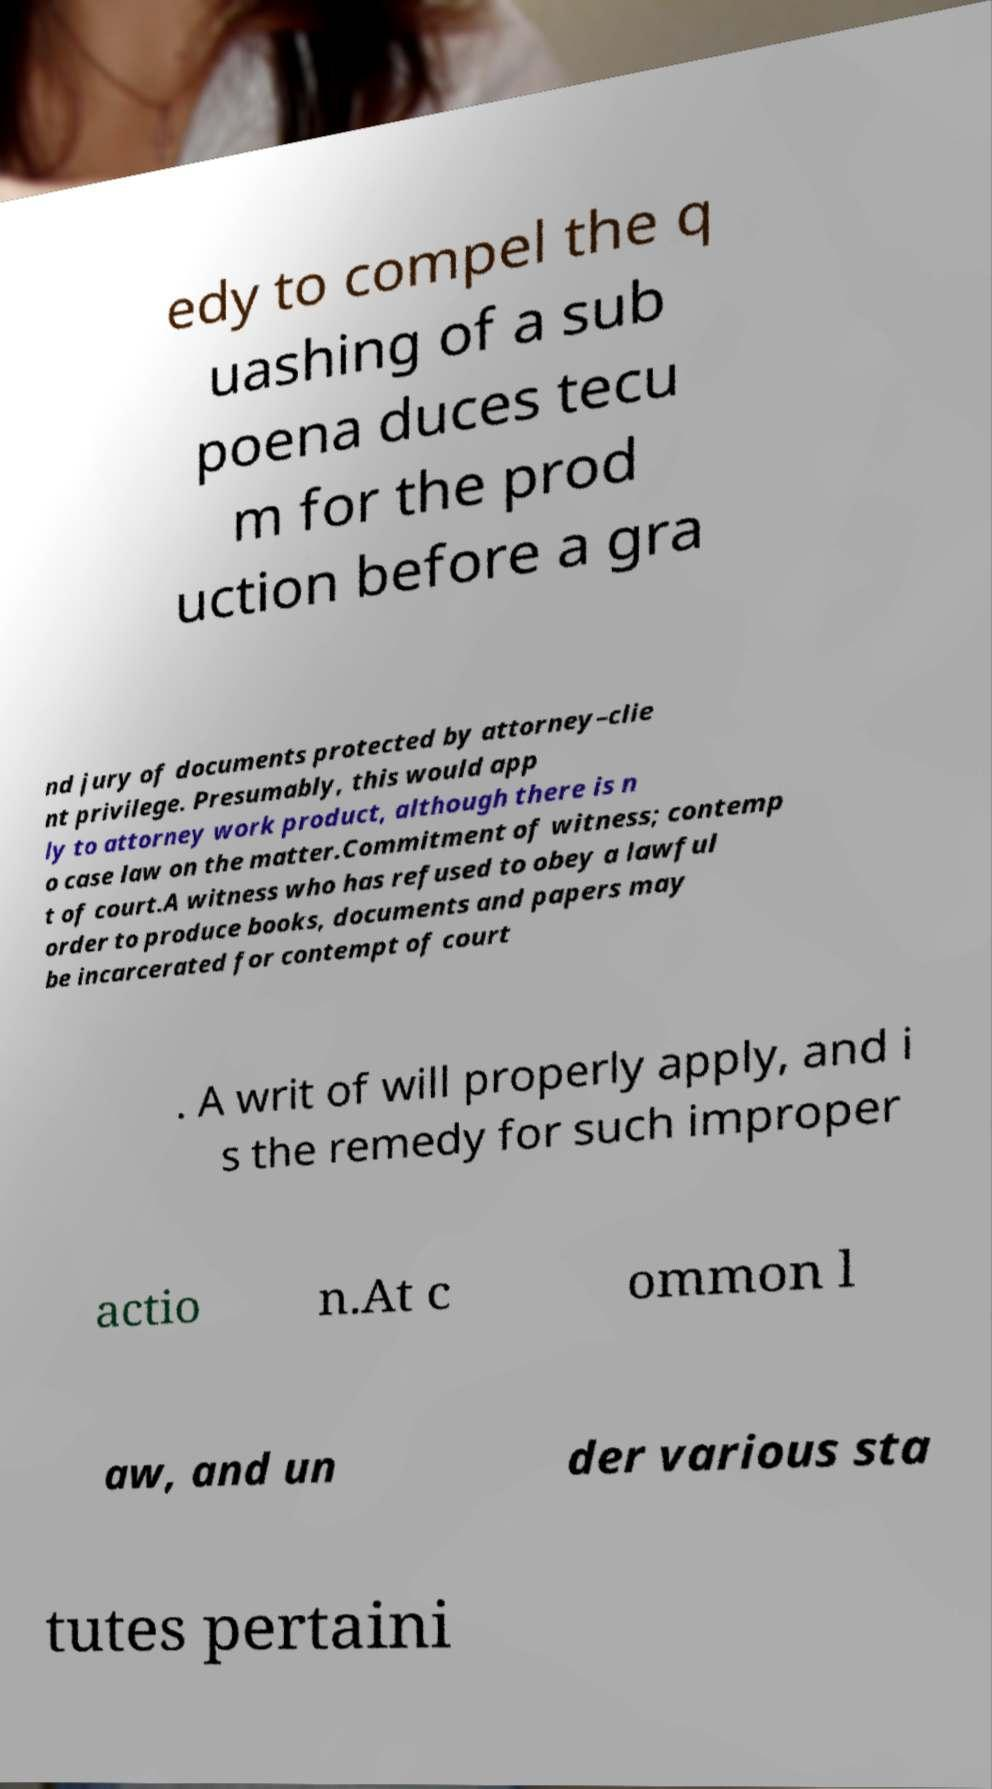Can you accurately transcribe the text from the provided image for me? edy to compel the q uashing of a sub poena duces tecu m for the prod uction before a gra nd jury of documents protected by attorney–clie nt privilege. Presumably, this would app ly to attorney work product, although there is n o case law on the matter.Commitment of witness; contemp t of court.A witness who has refused to obey a lawful order to produce books, documents and papers may be incarcerated for contempt of court . A writ of will properly apply, and i s the remedy for such improper actio n.At c ommon l aw, and un der various sta tutes pertaini 